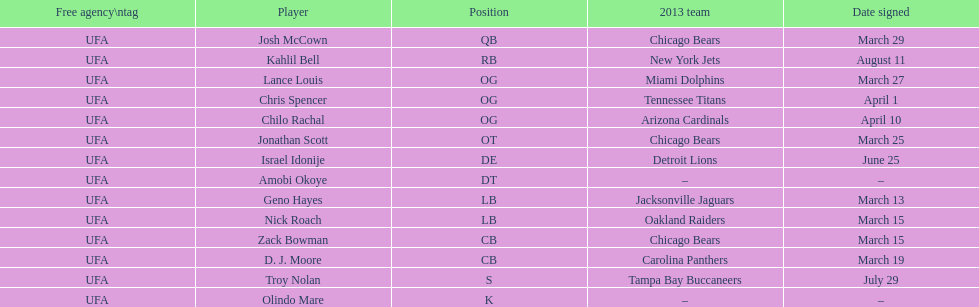What is the total of 2013 teams on the chart? 10. 